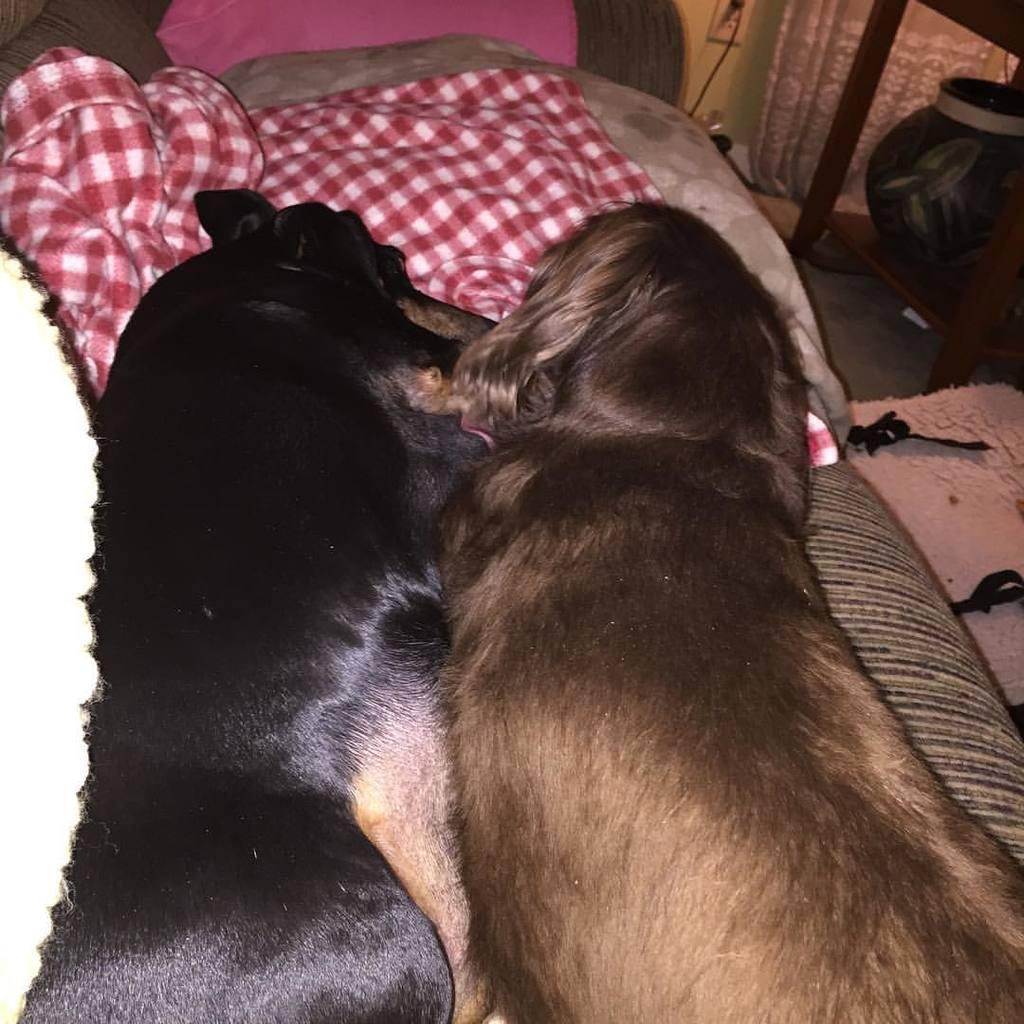Could you give a brief overview of what you see in this image? In this picture there are two dogs sleeping in a sofa and there is a pillow and a red color bed sheet in front of it and there are some other objects in the right corner. 